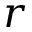Convert formula to latex. <formula><loc_0><loc_0><loc_500><loc_500>r</formula> 